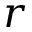Convert formula to latex. <formula><loc_0><loc_0><loc_500><loc_500>r</formula> 